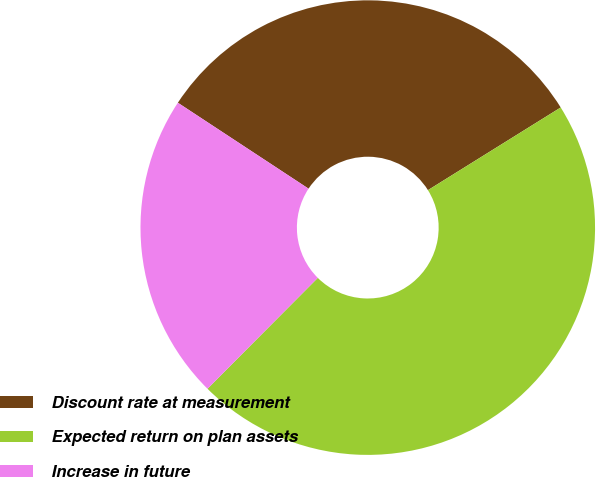Convert chart to OTSL. <chart><loc_0><loc_0><loc_500><loc_500><pie_chart><fcel>Discount rate at measurement<fcel>Expected return on plan assets<fcel>Increase in future<nl><fcel>31.88%<fcel>46.32%<fcel>21.8%<nl></chart> 